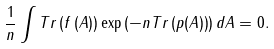<formula> <loc_0><loc_0><loc_500><loc_500>\frac { 1 } { n } \int T r \left ( f \left ( A \right ) \right ) \exp \left ( - n T r \left ( p ( A ) \right ) \right ) d A = 0 .</formula> 